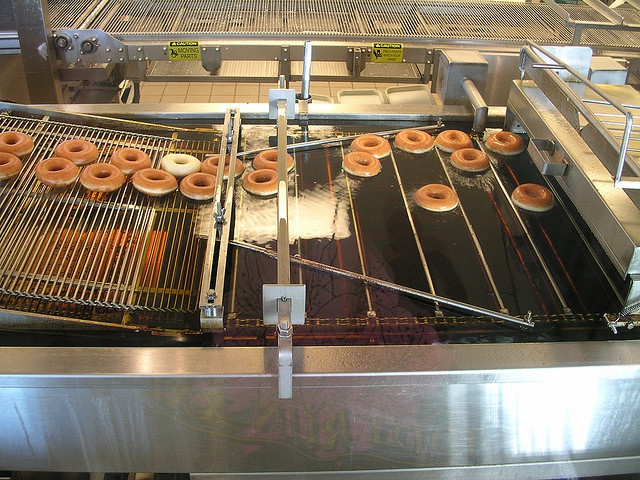Describe the objects in this image and their specific colors. I can see donut in black, brown, maroon, and salmon tones, donut in black, tan, brown, orange, and salmon tones, donut in black, tan, orange, red, and salmon tones, donut in black, orange, brown, and salmon tones, and donut in black, orange, gray, and red tones in this image. 